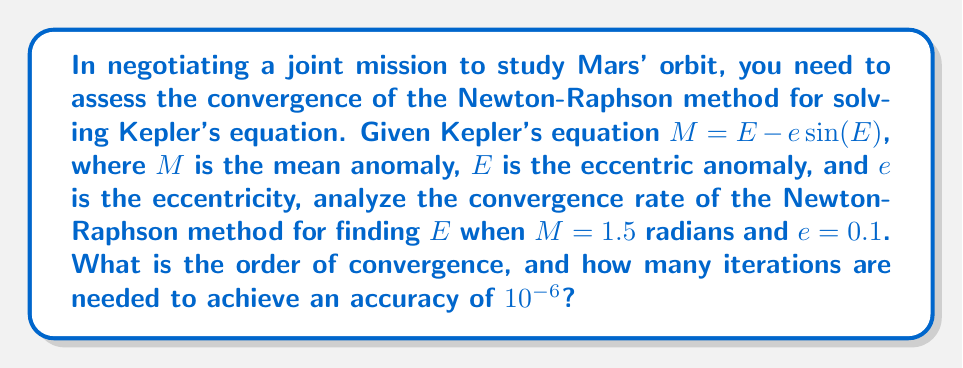Give your solution to this math problem. To analyze the convergence of the Newton-Raphson method for Kepler's equation, we follow these steps:

1) The Newton-Raphson iteration for Kepler's equation is given by:

   $$E_{n+1} = E_n - \frac{E_n - e\sin(E_n) - M}{1 - e\cos(E_n)}$$

2) The order of convergence for the Newton-Raphson method is generally quadratic (2nd order) for well-behaved functions.

3) To estimate the number of iterations, we use the formula:

   $$n \approx \frac{\log(\frac{\log(\epsilon)}{\log(|E_1 - E_0|)})}{\log(2)}$$

   where $\epsilon$ is the desired accuracy and $E_0, E_1$ are the initial guesses.

4) For our initial guess, we can use $E_0 = M = 1.5$.

5) Calculate $E_1$:
   $$E_1 = 1.5 - \frac{1.5 - 0.1\sin(1.5) - 1.5}{1 - 0.1\cos(1.5)} \approx 1.5708$$

6) Now we can estimate the number of iterations:
   $$n \approx \frac{\log(\frac{\log(10^{-6})}{\log(|1.5708 - 1.5|)})}{\log(2)} \approx 3.78$$

7) Rounding up, we need 4 iterations to achieve the desired accuracy.
Answer: Quadratic convergence; 4 iterations 